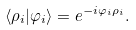<formula> <loc_0><loc_0><loc_500><loc_500>\left \langle \rho _ { i } | \varphi _ { i } \right \rangle = e ^ { - i \varphi _ { i } \rho _ { i } } .</formula> 